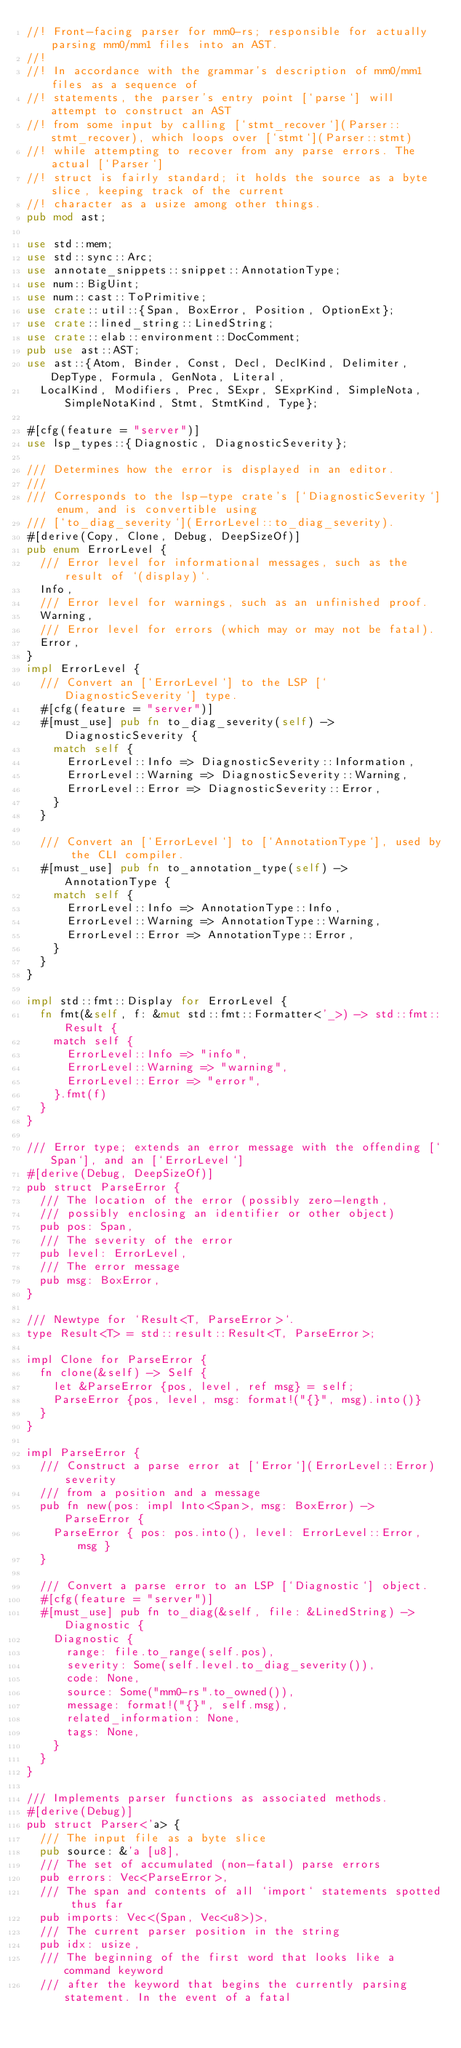<code> <loc_0><loc_0><loc_500><loc_500><_Rust_>//! Front-facing parser for mm0-rs; responsible for actually parsing mm0/mm1 files into an AST.
//!
//! In accordance with the grammar's description of mm0/mm1 files as a sequence of
//! statements, the parser's entry point [`parse`] will attempt to construct an AST
//! from some input by calling [`stmt_recover`](Parser::stmt_recover), which loops over [`stmt`](Parser::stmt)
//! while attempting to recover from any parse errors. The actual [`Parser`]
//! struct is fairly standard; it holds the source as a byte slice, keeping track of the current
//! character as a usize among other things.
pub mod ast;

use std::mem;
use std::sync::Arc;
use annotate_snippets::snippet::AnnotationType;
use num::BigUint;
use num::cast::ToPrimitive;
use crate::util::{Span, BoxError, Position, OptionExt};
use crate::lined_string::LinedString;
use crate::elab::environment::DocComment;
pub use ast::AST;
use ast::{Atom, Binder, Const, Decl, DeclKind, Delimiter, DepType, Formula, GenNota, Literal,
  LocalKind, Modifiers, Prec, SExpr, SExprKind, SimpleNota, SimpleNotaKind, Stmt, StmtKind, Type};

#[cfg(feature = "server")]
use lsp_types::{Diagnostic, DiagnosticSeverity};

/// Determines how the error is displayed in an editor.
///
/// Corresponds to the lsp-type crate's [`DiagnosticSeverity`] enum, and is convertible using
/// [`to_diag_severity`](ErrorLevel::to_diag_severity).
#[derive(Copy, Clone, Debug, DeepSizeOf)]
pub enum ErrorLevel {
  /// Error level for informational messages, such as the result of `(display)`.
  Info,
  /// Error level for warnings, such as an unfinished proof.
  Warning,
  /// Error level for errors (which may or may not be fatal).
  Error,
}
impl ErrorLevel {
  /// Convert an [`ErrorLevel`] to the LSP [`DiagnosticSeverity`] type.
  #[cfg(feature = "server")]
  #[must_use] pub fn to_diag_severity(self) -> DiagnosticSeverity {
    match self {
      ErrorLevel::Info => DiagnosticSeverity::Information,
      ErrorLevel::Warning => DiagnosticSeverity::Warning,
      ErrorLevel::Error => DiagnosticSeverity::Error,
    }
  }

  /// Convert an [`ErrorLevel`] to [`AnnotationType`], used by the CLI compiler.
  #[must_use] pub fn to_annotation_type(self) -> AnnotationType {
    match self {
      ErrorLevel::Info => AnnotationType::Info,
      ErrorLevel::Warning => AnnotationType::Warning,
      ErrorLevel::Error => AnnotationType::Error,
    }
  }
}

impl std::fmt::Display for ErrorLevel {
  fn fmt(&self, f: &mut std::fmt::Formatter<'_>) -> std::fmt::Result {
    match self {
      ErrorLevel::Info => "info",
      ErrorLevel::Warning => "warning",
      ErrorLevel::Error => "error",
    }.fmt(f)
  }
}

/// Error type; extends an error message with the offending [`Span`], and an [`ErrorLevel`]
#[derive(Debug, DeepSizeOf)]
pub struct ParseError {
  /// The location of the error (possibly zero-length,
  /// possibly enclosing an identifier or other object)
  pub pos: Span,
  /// The severity of the error
  pub level: ErrorLevel,
  /// The error message
  pub msg: BoxError,
}

/// Newtype for `Result<T, ParseError>`.
type Result<T> = std::result::Result<T, ParseError>;

impl Clone for ParseError {
  fn clone(&self) -> Self {
    let &ParseError {pos, level, ref msg} = self;
    ParseError {pos, level, msg: format!("{}", msg).into()}
  }
}

impl ParseError {
  /// Construct a parse error at [`Error`](ErrorLevel::Error) severity
  /// from a position and a message
  pub fn new(pos: impl Into<Span>, msg: BoxError) -> ParseError {
    ParseError { pos: pos.into(), level: ErrorLevel::Error, msg }
  }

  /// Convert a parse error to an LSP [`Diagnostic`] object.
  #[cfg(feature = "server")]
  #[must_use] pub fn to_diag(&self, file: &LinedString) -> Diagnostic {
    Diagnostic {
      range: file.to_range(self.pos),
      severity: Some(self.level.to_diag_severity()),
      code: None,
      source: Some("mm0-rs".to_owned()),
      message: format!("{}", self.msg),
      related_information: None,
      tags: None,
    }
  }
}

/// Implements parser functions as associated methods.
#[derive(Debug)]
pub struct Parser<'a> {
  /// The input file as a byte slice
  pub source: &'a [u8],
  /// The set of accumulated (non-fatal) parse errors
  pub errors: Vec<ParseError>,
  /// The span and contents of all `import` statements spotted thus far
  pub imports: Vec<(Span, Vec<u8>)>,
  /// The current parser position in the string
  pub idx: usize,
  /// The beginning of the first word that looks like a command keyword
  /// after the keyword that begins the currently parsing statement. In the event of a fatal</code> 